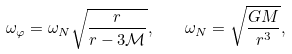<formula> <loc_0><loc_0><loc_500><loc_500>\omega _ { \varphi } = \omega _ { N } \sqrt { \frac { r } { r - 3 \mathcal { M } } } , \quad \omega _ { N } = \sqrt { \frac { G M } { r ^ { 3 } } } ,</formula> 